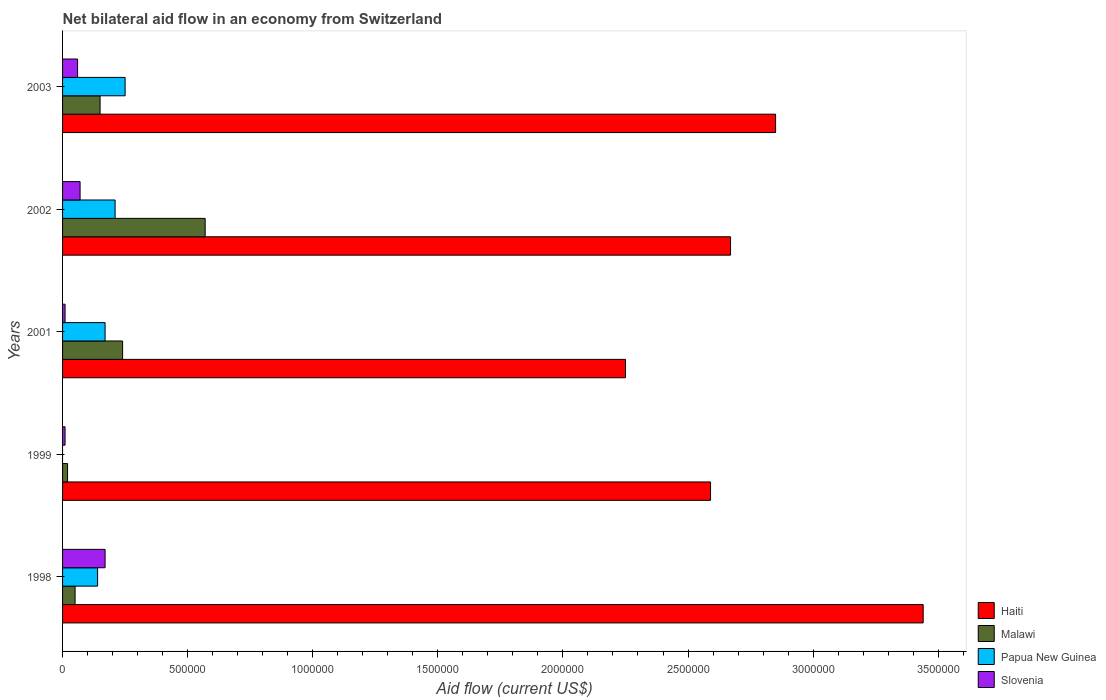How many different coloured bars are there?
Offer a terse response. 4. How many groups of bars are there?
Provide a succinct answer. 5. How many bars are there on the 2nd tick from the top?
Your response must be concise. 4. What is the net bilateral aid flow in Papua New Guinea in 2001?
Offer a very short reply. 1.70e+05. Across all years, what is the maximum net bilateral aid flow in Papua New Guinea?
Your answer should be very brief. 2.50e+05. What is the total net bilateral aid flow in Slovenia in the graph?
Keep it short and to the point. 3.20e+05. What is the difference between the net bilateral aid flow in Malawi in 1998 and the net bilateral aid flow in Haiti in 1999?
Make the answer very short. -2.54e+06. What is the average net bilateral aid flow in Haiti per year?
Keep it short and to the point. 2.76e+06. In the year 2002, what is the difference between the net bilateral aid flow in Papua New Guinea and net bilateral aid flow in Malawi?
Provide a short and direct response. -3.60e+05. In how many years, is the net bilateral aid flow in Papua New Guinea greater than 1400000 US$?
Offer a terse response. 0. What is the ratio of the net bilateral aid flow in Slovenia in 1998 to that in 2002?
Provide a succinct answer. 2.43. Is the difference between the net bilateral aid flow in Papua New Guinea in 1998 and 2002 greater than the difference between the net bilateral aid flow in Malawi in 1998 and 2002?
Your response must be concise. Yes. Is it the case that in every year, the sum of the net bilateral aid flow in Malawi and net bilateral aid flow in Papua New Guinea is greater than the net bilateral aid flow in Haiti?
Your answer should be compact. No. How many bars are there?
Provide a succinct answer. 19. Are all the bars in the graph horizontal?
Give a very brief answer. Yes. How many years are there in the graph?
Your response must be concise. 5. What is the difference between two consecutive major ticks on the X-axis?
Ensure brevity in your answer.  5.00e+05. Are the values on the major ticks of X-axis written in scientific E-notation?
Your answer should be very brief. No. Does the graph contain grids?
Your answer should be very brief. No. What is the title of the graph?
Your answer should be very brief. Net bilateral aid flow in an economy from Switzerland. What is the label or title of the X-axis?
Make the answer very short. Aid flow (current US$). What is the Aid flow (current US$) in Haiti in 1998?
Ensure brevity in your answer.  3.44e+06. What is the Aid flow (current US$) in Papua New Guinea in 1998?
Keep it short and to the point. 1.40e+05. What is the Aid flow (current US$) in Haiti in 1999?
Ensure brevity in your answer.  2.59e+06. What is the Aid flow (current US$) in Papua New Guinea in 1999?
Give a very brief answer. 0. What is the Aid flow (current US$) in Haiti in 2001?
Your answer should be compact. 2.25e+06. What is the Aid flow (current US$) of Papua New Guinea in 2001?
Keep it short and to the point. 1.70e+05. What is the Aid flow (current US$) of Slovenia in 2001?
Offer a terse response. 10000. What is the Aid flow (current US$) in Haiti in 2002?
Provide a short and direct response. 2.67e+06. What is the Aid flow (current US$) of Malawi in 2002?
Ensure brevity in your answer.  5.70e+05. What is the Aid flow (current US$) in Papua New Guinea in 2002?
Your response must be concise. 2.10e+05. What is the Aid flow (current US$) in Haiti in 2003?
Provide a short and direct response. 2.85e+06. Across all years, what is the maximum Aid flow (current US$) in Haiti?
Keep it short and to the point. 3.44e+06. Across all years, what is the maximum Aid flow (current US$) of Malawi?
Your answer should be very brief. 5.70e+05. Across all years, what is the minimum Aid flow (current US$) in Haiti?
Keep it short and to the point. 2.25e+06. Across all years, what is the minimum Aid flow (current US$) in Malawi?
Your response must be concise. 2.00e+04. Across all years, what is the minimum Aid flow (current US$) of Slovenia?
Keep it short and to the point. 10000. What is the total Aid flow (current US$) in Haiti in the graph?
Keep it short and to the point. 1.38e+07. What is the total Aid flow (current US$) in Malawi in the graph?
Your answer should be compact. 1.03e+06. What is the total Aid flow (current US$) of Papua New Guinea in the graph?
Your response must be concise. 7.70e+05. What is the difference between the Aid flow (current US$) in Haiti in 1998 and that in 1999?
Ensure brevity in your answer.  8.50e+05. What is the difference between the Aid flow (current US$) of Malawi in 1998 and that in 1999?
Make the answer very short. 3.00e+04. What is the difference between the Aid flow (current US$) in Haiti in 1998 and that in 2001?
Your response must be concise. 1.19e+06. What is the difference between the Aid flow (current US$) of Malawi in 1998 and that in 2001?
Your answer should be compact. -1.90e+05. What is the difference between the Aid flow (current US$) in Papua New Guinea in 1998 and that in 2001?
Offer a very short reply. -3.00e+04. What is the difference between the Aid flow (current US$) of Haiti in 1998 and that in 2002?
Provide a succinct answer. 7.70e+05. What is the difference between the Aid flow (current US$) of Malawi in 1998 and that in 2002?
Your answer should be compact. -5.20e+05. What is the difference between the Aid flow (current US$) of Papua New Guinea in 1998 and that in 2002?
Provide a short and direct response. -7.00e+04. What is the difference between the Aid flow (current US$) of Slovenia in 1998 and that in 2002?
Ensure brevity in your answer.  1.00e+05. What is the difference between the Aid flow (current US$) of Haiti in 1998 and that in 2003?
Your answer should be very brief. 5.90e+05. What is the difference between the Aid flow (current US$) in Malawi in 1998 and that in 2003?
Provide a short and direct response. -1.00e+05. What is the difference between the Aid flow (current US$) of Slovenia in 1999 and that in 2001?
Your answer should be very brief. 0. What is the difference between the Aid flow (current US$) of Haiti in 1999 and that in 2002?
Your answer should be very brief. -8.00e+04. What is the difference between the Aid flow (current US$) in Malawi in 1999 and that in 2002?
Offer a terse response. -5.50e+05. What is the difference between the Aid flow (current US$) of Malawi in 1999 and that in 2003?
Provide a short and direct response. -1.30e+05. What is the difference between the Aid flow (current US$) of Slovenia in 1999 and that in 2003?
Offer a very short reply. -5.00e+04. What is the difference between the Aid flow (current US$) in Haiti in 2001 and that in 2002?
Your answer should be very brief. -4.20e+05. What is the difference between the Aid flow (current US$) in Malawi in 2001 and that in 2002?
Keep it short and to the point. -3.30e+05. What is the difference between the Aid flow (current US$) of Haiti in 2001 and that in 2003?
Provide a succinct answer. -6.00e+05. What is the difference between the Aid flow (current US$) of Slovenia in 2001 and that in 2003?
Keep it short and to the point. -5.00e+04. What is the difference between the Aid flow (current US$) of Haiti in 2002 and that in 2003?
Keep it short and to the point. -1.80e+05. What is the difference between the Aid flow (current US$) of Haiti in 1998 and the Aid flow (current US$) of Malawi in 1999?
Provide a short and direct response. 3.42e+06. What is the difference between the Aid flow (current US$) of Haiti in 1998 and the Aid flow (current US$) of Slovenia in 1999?
Offer a very short reply. 3.43e+06. What is the difference between the Aid flow (current US$) of Malawi in 1998 and the Aid flow (current US$) of Slovenia in 1999?
Make the answer very short. 4.00e+04. What is the difference between the Aid flow (current US$) of Haiti in 1998 and the Aid flow (current US$) of Malawi in 2001?
Provide a short and direct response. 3.20e+06. What is the difference between the Aid flow (current US$) of Haiti in 1998 and the Aid flow (current US$) of Papua New Guinea in 2001?
Your answer should be compact. 3.27e+06. What is the difference between the Aid flow (current US$) in Haiti in 1998 and the Aid flow (current US$) in Slovenia in 2001?
Provide a short and direct response. 3.43e+06. What is the difference between the Aid flow (current US$) in Malawi in 1998 and the Aid flow (current US$) in Papua New Guinea in 2001?
Make the answer very short. -1.20e+05. What is the difference between the Aid flow (current US$) in Papua New Guinea in 1998 and the Aid flow (current US$) in Slovenia in 2001?
Your answer should be very brief. 1.30e+05. What is the difference between the Aid flow (current US$) in Haiti in 1998 and the Aid flow (current US$) in Malawi in 2002?
Your response must be concise. 2.87e+06. What is the difference between the Aid flow (current US$) of Haiti in 1998 and the Aid flow (current US$) of Papua New Guinea in 2002?
Make the answer very short. 3.23e+06. What is the difference between the Aid flow (current US$) in Haiti in 1998 and the Aid flow (current US$) in Slovenia in 2002?
Keep it short and to the point. 3.37e+06. What is the difference between the Aid flow (current US$) of Malawi in 1998 and the Aid flow (current US$) of Papua New Guinea in 2002?
Keep it short and to the point. -1.60e+05. What is the difference between the Aid flow (current US$) of Malawi in 1998 and the Aid flow (current US$) of Slovenia in 2002?
Provide a succinct answer. -2.00e+04. What is the difference between the Aid flow (current US$) in Haiti in 1998 and the Aid flow (current US$) in Malawi in 2003?
Your answer should be compact. 3.29e+06. What is the difference between the Aid flow (current US$) in Haiti in 1998 and the Aid flow (current US$) in Papua New Guinea in 2003?
Keep it short and to the point. 3.19e+06. What is the difference between the Aid flow (current US$) of Haiti in 1998 and the Aid flow (current US$) of Slovenia in 2003?
Your response must be concise. 3.38e+06. What is the difference between the Aid flow (current US$) of Malawi in 1998 and the Aid flow (current US$) of Slovenia in 2003?
Make the answer very short. -10000. What is the difference between the Aid flow (current US$) of Papua New Guinea in 1998 and the Aid flow (current US$) of Slovenia in 2003?
Offer a terse response. 8.00e+04. What is the difference between the Aid flow (current US$) in Haiti in 1999 and the Aid flow (current US$) in Malawi in 2001?
Your answer should be very brief. 2.35e+06. What is the difference between the Aid flow (current US$) of Haiti in 1999 and the Aid flow (current US$) of Papua New Guinea in 2001?
Keep it short and to the point. 2.42e+06. What is the difference between the Aid flow (current US$) in Haiti in 1999 and the Aid flow (current US$) in Slovenia in 2001?
Provide a short and direct response. 2.58e+06. What is the difference between the Aid flow (current US$) in Malawi in 1999 and the Aid flow (current US$) in Papua New Guinea in 2001?
Offer a terse response. -1.50e+05. What is the difference between the Aid flow (current US$) in Malawi in 1999 and the Aid flow (current US$) in Slovenia in 2001?
Ensure brevity in your answer.  10000. What is the difference between the Aid flow (current US$) of Haiti in 1999 and the Aid flow (current US$) of Malawi in 2002?
Keep it short and to the point. 2.02e+06. What is the difference between the Aid flow (current US$) of Haiti in 1999 and the Aid flow (current US$) of Papua New Guinea in 2002?
Ensure brevity in your answer.  2.38e+06. What is the difference between the Aid flow (current US$) of Haiti in 1999 and the Aid flow (current US$) of Slovenia in 2002?
Provide a succinct answer. 2.52e+06. What is the difference between the Aid flow (current US$) of Malawi in 1999 and the Aid flow (current US$) of Papua New Guinea in 2002?
Provide a succinct answer. -1.90e+05. What is the difference between the Aid flow (current US$) of Malawi in 1999 and the Aid flow (current US$) of Slovenia in 2002?
Keep it short and to the point. -5.00e+04. What is the difference between the Aid flow (current US$) of Haiti in 1999 and the Aid flow (current US$) of Malawi in 2003?
Make the answer very short. 2.44e+06. What is the difference between the Aid flow (current US$) in Haiti in 1999 and the Aid flow (current US$) in Papua New Guinea in 2003?
Keep it short and to the point. 2.34e+06. What is the difference between the Aid flow (current US$) of Haiti in 1999 and the Aid flow (current US$) of Slovenia in 2003?
Offer a very short reply. 2.53e+06. What is the difference between the Aid flow (current US$) in Malawi in 1999 and the Aid flow (current US$) in Slovenia in 2003?
Your answer should be compact. -4.00e+04. What is the difference between the Aid flow (current US$) of Haiti in 2001 and the Aid flow (current US$) of Malawi in 2002?
Ensure brevity in your answer.  1.68e+06. What is the difference between the Aid flow (current US$) of Haiti in 2001 and the Aid flow (current US$) of Papua New Guinea in 2002?
Your answer should be compact. 2.04e+06. What is the difference between the Aid flow (current US$) of Haiti in 2001 and the Aid flow (current US$) of Slovenia in 2002?
Offer a terse response. 2.18e+06. What is the difference between the Aid flow (current US$) in Papua New Guinea in 2001 and the Aid flow (current US$) in Slovenia in 2002?
Your answer should be very brief. 1.00e+05. What is the difference between the Aid flow (current US$) of Haiti in 2001 and the Aid flow (current US$) of Malawi in 2003?
Offer a very short reply. 2.10e+06. What is the difference between the Aid flow (current US$) in Haiti in 2001 and the Aid flow (current US$) in Slovenia in 2003?
Make the answer very short. 2.19e+06. What is the difference between the Aid flow (current US$) in Malawi in 2001 and the Aid flow (current US$) in Papua New Guinea in 2003?
Offer a very short reply. -10000. What is the difference between the Aid flow (current US$) of Malawi in 2001 and the Aid flow (current US$) of Slovenia in 2003?
Keep it short and to the point. 1.80e+05. What is the difference between the Aid flow (current US$) in Papua New Guinea in 2001 and the Aid flow (current US$) in Slovenia in 2003?
Your answer should be very brief. 1.10e+05. What is the difference between the Aid flow (current US$) in Haiti in 2002 and the Aid flow (current US$) in Malawi in 2003?
Your answer should be very brief. 2.52e+06. What is the difference between the Aid flow (current US$) in Haiti in 2002 and the Aid flow (current US$) in Papua New Guinea in 2003?
Keep it short and to the point. 2.42e+06. What is the difference between the Aid flow (current US$) of Haiti in 2002 and the Aid flow (current US$) of Slovenia in 2003?
Make the answer very short. 2.61e+06. What is the difference between the Aid flow (current US$) in Malawi in 2002 and the Aid flow (current US$) in Slovenia in 2003?
Give a very brief answer. 5.10e+05. What is the difference between the Aid flow (current US$) in Papua New Guinea in 2002 and the Aid flow (current US$) in Slovenia in 2003?
Ensure brevity in your answer.  1.50e+05. What is the average Aid flow (current US$) of Haiti per year?
Provide a short and direct response. 2.76e+06. What is the average Aid flow (current US$) in Malawi per year?
Your response must be concise. 2.06e+05. What is the average Aid flow (current US$) in Papua New Guinea per year?
Offer a very short reply. 1.54e+05. What is the average Aid flow (current US$) of Slovenia per year?
Offer a very short reply. 6.40e+04. In the year 1998, what is the difference between the Aid flow (current US$) in Haiti and Aid flow (current US$) in Malawi?
Ensure brevity in your answer.  3.39e+06. In the year 1998, what is the difference between the Aid flow (current US$) of Haiti and Aid flow (current US$) of Papua New Guinea?
Give a very brief answer. 3.30e+06. In the year 1998, what is the difference between the Aid flow (current US$) of Haiti and Aid flow (current US$) of Slovenia?
Ensure brevity in your answer.  3.27e+06. In the year 1998, what is the difference between the Aid flow (current US$) of Malawi and Aid flow (current US$) of Papua New Guinea?
Your answer should be compact. -9.00e+04. In the year 1998, what is the difference between the Aid flow (current US$) of Malawi and Aid flow (current US$) of Slovenia?
Ensure brevity in your answer.  -1.20e+05. In the year 1998, what is the difference between the Aid flow (current US$) in Papua New Guinea and Aid flow (current US$) in Slovenia?
Provide a succinct answer. -3.00e+04. In the year 1999, what is the difference between the Aid flow (current US$) of Haiti and Aid flow (current US$) of Malawi?
Offer a terse response. 2.57e+06. In the year 1999, what is the difference between the Aid flow (current US$) in Haiti and Aid flow (current US$) in Slovenia?
Offer a terse response. 2.58e+06. In the year 1999, what is the difference between the Aid flow (current US$) in Malawi and Aid flow (current US$) in Slovenia?
Provide a succinct answer. 10000. In the year 2001, what is the difference between the Aid flow (current US$) in Haiti and Aid flow (current US$) in Malawi?
Provide a succinct answer. 2.01e+06. In the year 2001, what is the difference between the Aid flow (current US$) in Haiti and Aid flow (current US$) in Papua New Guinea?
Give a very brief answer. 2.08e+06. In the year 2001, what is the difference between the Aid flow (current US$) in Haiti and Aid flow (current US$) in Slovenia?
Your answer should be compact. 2.24e+06. In the year 2001, what is the difference between the Aid flow (current US$) in Malawi and Aid flow (current US$) in Papua New Guinea?
Provide a short and direct response. 7.00e+04. In the year 2002, what is the difference between the Aid flow (current US$) in Haiti and Aid flow (current US$) in Malawi?
Offer a very short reply. 2.10e+06. In the year 2002, what is the difference between the Aid flow (current US$) of Haiti and Aid flow (current US$) of Papua New Guinea?
Ensure brevity in your answer.  2.46e+06. In the year 2002, what is the difference between the Aid flow (current US$) of Haiti and Aid flow (current US$) of Slovenia?
Your response must be concise. 2.60e+06. In the year 2003, what is the difference between the Aid flow (current US$) of Haiti and Aid flow (current US$) of Malawi?
Your answer should be compact. 2.70e+06. In the year 2003, what is the difference between the Aid flow (current US$) of Haiti and Aid flow (current US$) of Papua New Guinea?
Give a very brief answer. 2.60e+06. In the year 2003, what is the difference between the Aid flow (current US$) in Haiti and Aid flow (current US$) in Slovenia?
Your answer should be compact. 2.79e+06. In the year 2003, what is the difference between the Aid flow (current US$) of Papua New Guinea and Aid flow (current US$) of Slovenia?
Your answer should be very brief. 1.90e+05. What is the ratio of the Aid flow (current US$) of Haiti in 1998 to that in 1999?
Ensure brevity in your answer.  1.33. What is the ratio of the Aid flow (current US$) in Slovenia in 1998 to that in 1999?
Offer a very short reply. 17. What is the ratio of the Aid flow (current US$) of Haiti in 1998 to that in 2001?
Give a very brief answer. 1.53. What is the ratio of the Aid flow (current US$) in Malawi in 1998 to that in 2001?
Your answer should be very brief. 0.21. What is the ratio of the Aid flow (current US$) in Papua New Guinea in 1998 to that in 2001?
Your response must be concise. 0.82. What is the ratio of the Aid flow (current US$) in Slovenia in 1998 to that in 2001?
Your response must be concise. 17. What is the ratio of the Aid flow (current US$) in Haiti in 1998 to that in 2002?
Your answer should be compact. 1.29. What is the ratio of the Aid flow (current US$) in Malawi in 1998 to that in 2002?
Make the answer very short. 0.09. What is the ratio of the Aid flow (current US$) of Papua New Guinea in 1998 to that in 2002?
Give a very brief answer. 0.67. What is the ratio of the Aid flow (current US$) of Slovenia in 1998 to that in 2002?
Offer a terse response. 2.43. What is the ratio of the Aid flow (current US$) in Haiti in 1998 to that in 2003?
Your answer should be compact. 1.21. What is the ratio of the Aid flow (current US$) of Papua New Guinea in 1998 to that in 2003?
Provide a succinct answer. 0.56. What is the ratio of the Aid flow (current US$) of Slovenia in 1998 to that in 2003?
Your answer should be very brief. 2.83. What is the ratio of the Aid flow (current US$) in Haiti in 1999 to that in 2001?
Your response must be concise. 1.15. What is the ratio of the Aid flow (current US$) of Malawi in 1999 to that in 2001?
Provide a short and direct response. 0.08. What is the ratio of the Aid flow (current US$) in Malawi in 1999 to that in 2002?
Provide a succinct answer. 0.04. What is the ratio of the Aid flow (current US$) in Slovenia in 1999 to that in 2002?
Keep it short and to the point. 0.14. What is the ratio of the Aid flow (current US$) of Haiti in 1999 to that in 2003?
Provide a short and direct response. 0.91. What is the ratio of the Aid flow (current US$) of Malawi in 1999 to that in 2003?
Make the answer very short. 0.13. What is the ratio of the Aid flow (current US$) in Slovenia in 1999 to that in 2003?
Offer a terse response. 0.17. What is the ratio of the Aid flow (current US$) of Haiti in 2001 to that in 2002?
Your answer should be compact. 0.84. What is the ratio of the Aid flow (current US$) of Malawi in 2001 to that in 2002?
Offer a terse response. 0.42. What is the ratio of the Aid flow (current US$) in Papua New Guinea in 2001 to that in 2002?
Your answer should be compact. 0.81. What is the ratio of the Aid flow (current US$) of Slovenia in 2001 to that in 2002?
Ensure brevity in your answer.  0.14. What is the ratio of the Aid flow (current US$) of Haiti in 2001 to that in 2003?
Offer a very short reply. 0.79. What is the ratio of the Aid flow (current US$) in Papua New Guinea in 2001 to that in 2003?
Ensure brevity in your answer.  0.68. What is the ratio of the Aid flow (current US$) in Slovenia in 2001 to that in 2003?
Your response must be concise. 0.17. What is the ratio of the Aid flow (current US$) in Haiti in 2002 to that in 2003?
Offer a very short reply. 0.94. What is the ratio of the Aid flow (current US$) in Malawi in 2002 to that in 2003?
Make the answer very short. 3.8. What is the ratio of the Aid flow (current US$) of Papua New Guinea in 2002 to that in 2003?
Your response must be concise. 0.84. What is the ratio of the Aid flow (current US$) of Slovenia in 2002 to that in 2003?
Provide a short and direct response. 1.17. What is the difference between the highest and the second highest Aid flow (current US$) in Haiti?
Provide a short and direct response. 5.90e+05. What is the difference between the highest and the second highest Aid flow (current US$) of Malawi?
Give a very brief answer. 3.30e+05. What is the difference between the highest and the second highest Aid flow (current US$) of Slovenia?
Provide a short and direct response. 1.00e+05. What is the difference between the highest and the lowest Aid flow (current US$) of Haiti?
Your answer should be compact. 1.19e+06. What is the difference between the highest and the lowest Aid flow (current US$) in Malawi?
Provide a succinct answer. 5.50e+05. What is the difference between the highest and the lowest Aid flow (current US$) in Papua New Guinea?
Your response must be concise. 2.50e+05. What is the difference between the highest and the lowest Aid flow (current US$) of Slovenia?
Your response must be concise. 1.60e+05. 